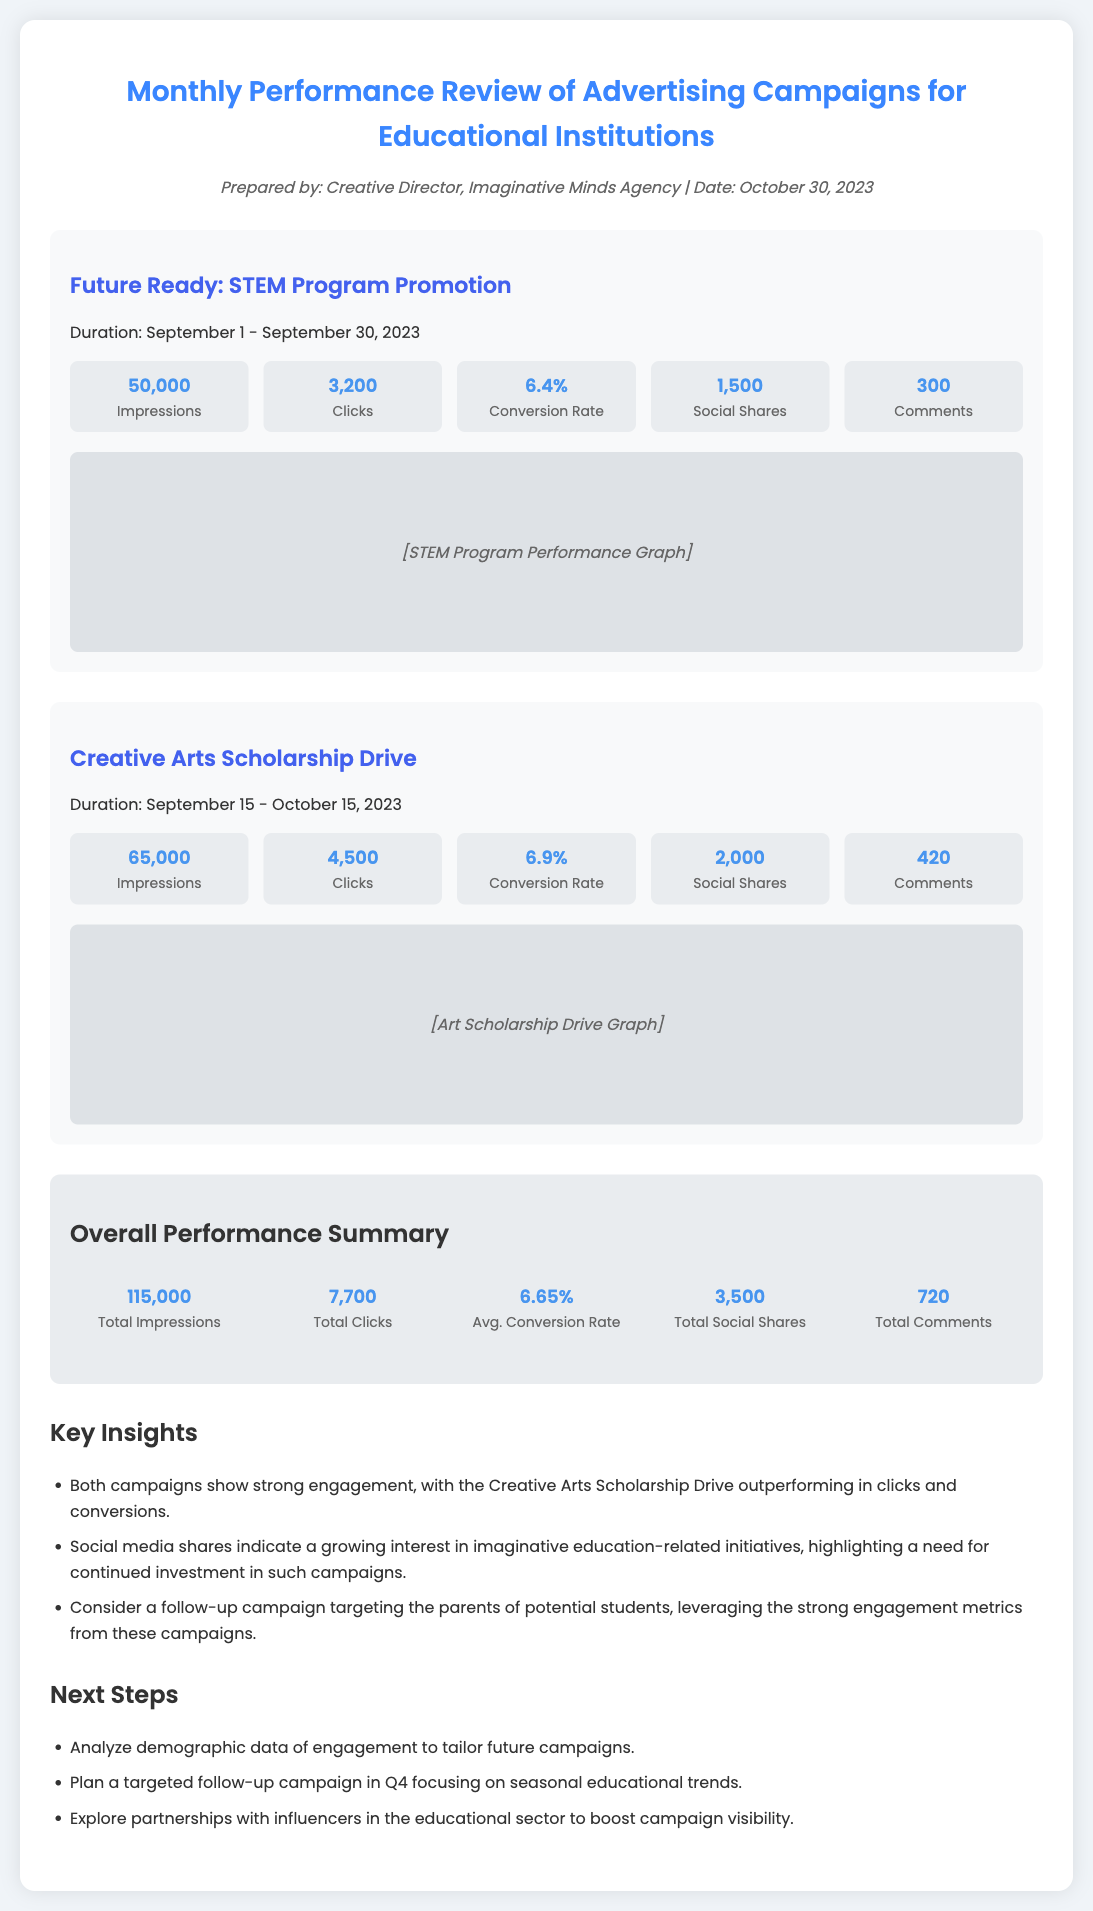What is the duration of the Creative Arts Scholarship Drive? The duration of the Creative Arts Scholarship Drive is mentioned in the document as September 15 - October 15, 2023.
Answer: September 15 - October 15, 2023 What is the conversion rate for the Future Ready: STEM Program Promotion? The document lists the conversion rate for the Future Ready: STEM Program Promotion as 6.4%.
Answer: 6.4% What is the total number of clicks across both campaigns? To find the total number of clicks, add the clicks from both campaigns: 3,200 + 4,500 = 7,700.
Answer: 7,700 Which campaign had the highest number of impressions? By comparing the impressions from both campaigns, the Creative Arts Scholarship Drive has the higher number at 65,000 compared to 50,000 for the STEM program.
Answer: Creative Arts Scholarship Drive What are the next steps suggested in the memo? The memo outlines Next Steps which include analyzing demographic data, planning a targeted follow-up campaign in Q4, and exploring partnerships with influencers.
Answer: Analyze demographic data, plan a follow-up campaign, explore partnerships What is the overall average conversion rate reported in the summary section? The average conversion rate reported in the summary section is 6.65%.
Answer: 6.65% How many total social shares were recorded across both campaigns? To find the total social shares, add them up: 1,500 + 2,000 = 3,500.
Answer: 3,500 Which campaign generated more comments, and how many? The Creative Arts Scholarship Drive generated more comments with a total of 420 compared to 300 for the STEM program.
Answer: Creative Arts Scholarship Drive, 420 What was the total number of impressions for both campaigns? The total number of impressions can be calculated by adding the impressions of both campaigns: 50,000 + 65,000 = 115,000.
Answer: 115,000 